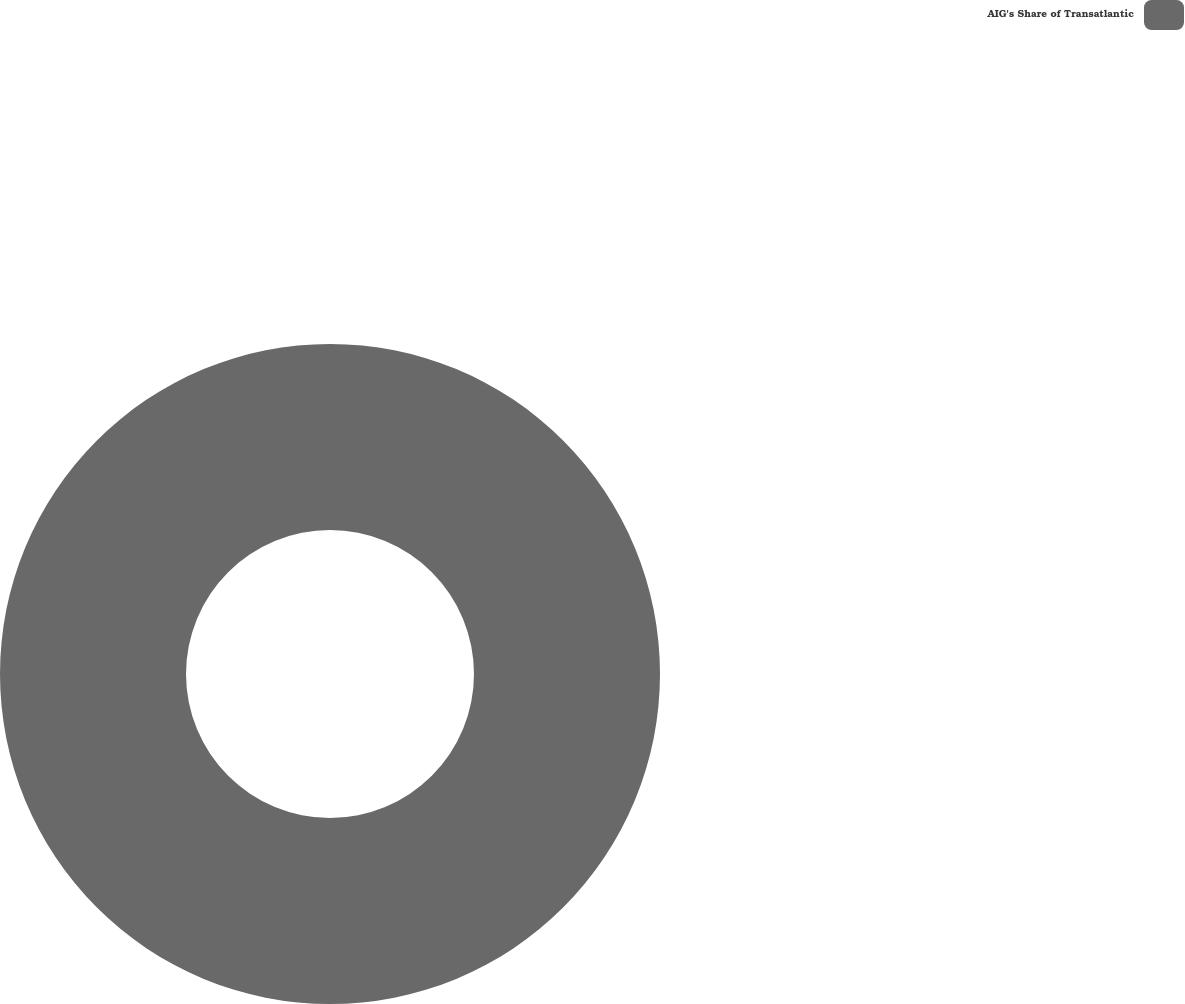<chart> <loc_0><loc_0><loc_500><loc_500><pie_chart><fcel>AIG's Share of Transatlantic<nl><fcel>100.0%<nl></chart> 